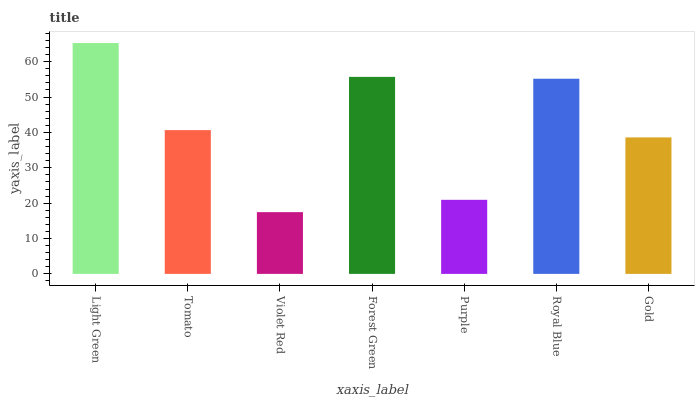Is Violet Red the minimum?
Answer yes or no. Yes. Is Light Green the maximum?
Answer yes or no. Yes. Is Tomato the minimum?
Answer yes or no. No. Is Tomato the maximum?
Answer yes or no. No. Is Light Green greater than Tomato?
Answer yes or no. Yes. Is Tomato less than Light Green?
Answer yes or no. Yes. Is Tomato greater than Light Green?
Answer yes or no. No. Is Light Green less than Tomato?
Answer yes or no. No. Is Tomato the high median?
Answer yes or no. Yes. Is Tomato the low median?
Answer yes or no. Yes. Is Light Green the high median?
Answer yes or no. No. Is Forest Green the low median?
Answer yes or no. No. 